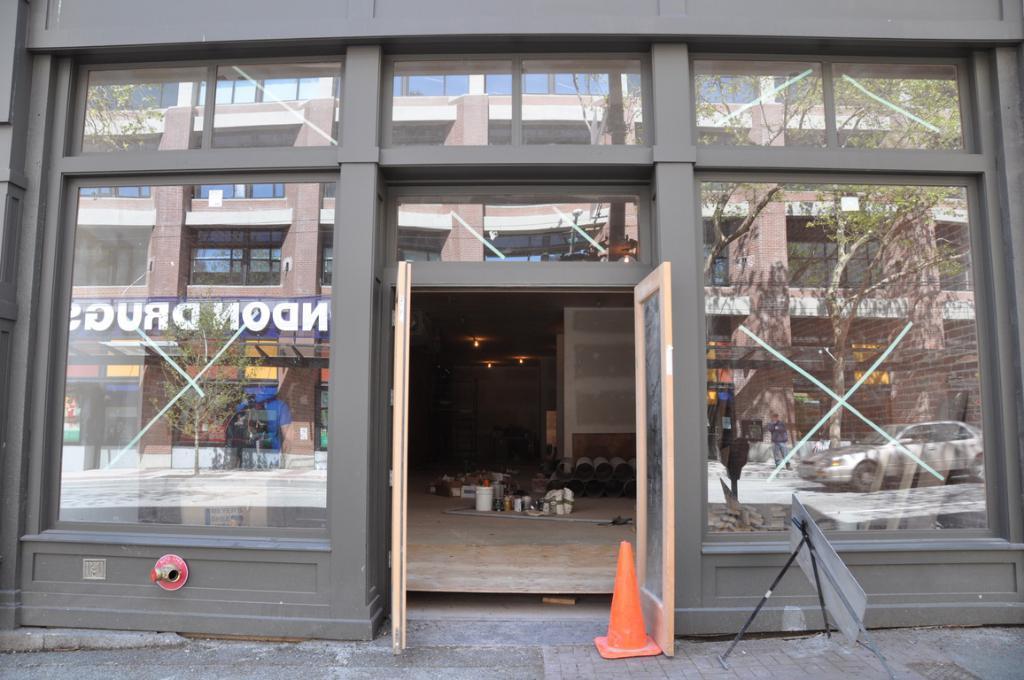How would you summarize this image in a sentence or two? In this picture I can see a building, there is a cone bar barricade and a board, there are some objects inside the building, and there is a reflection of a person, vehicle, building and trees. 